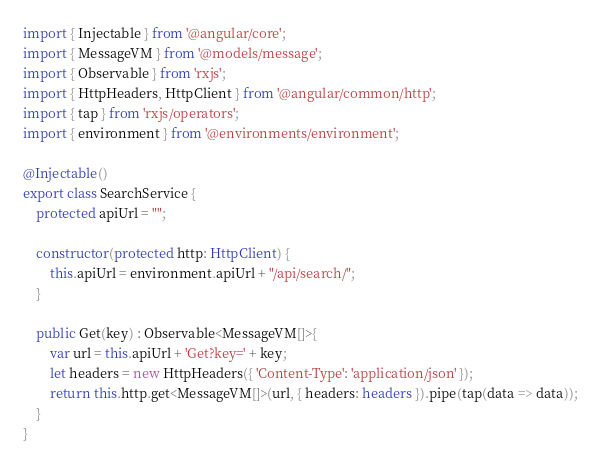<code> <loc_0><loc_0><loc_500><loc_500><_TypeScript_>import { Injectable } from '@angular/core';
import { MessageVM } from '@models/message';
import { Observable } from 'rxjs';
import { HttpHeaders, HttpClient } from '@angular/common/http';
import { tap } from 'rxjs/operators';
import { environment } from '@environments/environment';

@Injectable()
export class SearchService {
    protected apiUrl = "";  

    constructor(protected http: HttpClient) {          
        this.apiUrl = environment.apiUrl + "/api/search/";
    }  

    public Get(key) : Observable<MessageVM[]>{  
        var url = this.apiUrl + 'Get?key=' + key;  
        let headers = new HttpHeaders({ 'Content-Type': 'application/json' });  
        return this.http.get<MessageVM[]>(url, { headers: headers }).pipe(tap(data => data));  
    }  
}</code> 